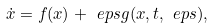<formula> <loc_0><loc_0><loc_500><loc_500>\dot { x } = f ( x ) + \ e p s g ( x , t , \ e p s ) ,</formula> 